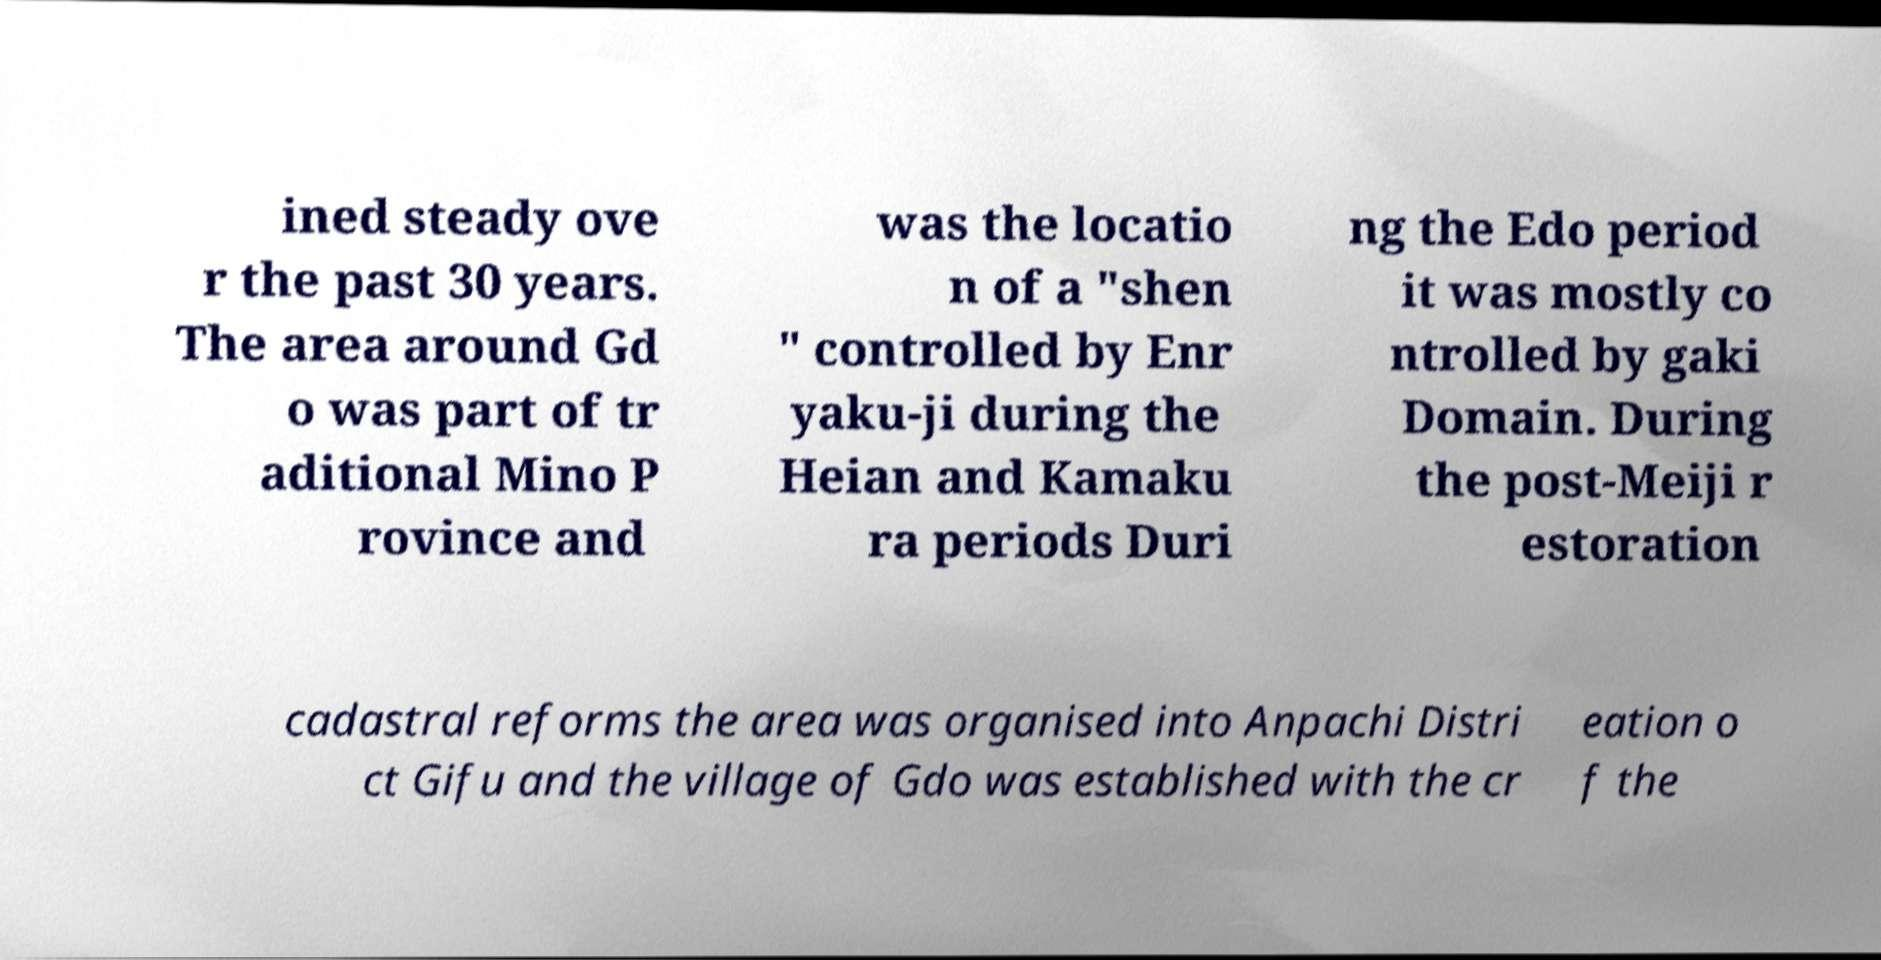Could you assist in decoding the text presented in this image and type it out clearly? ined steady ove r the past 30 years. The area around Gd o was part of tr aditional Mino P rovince and was the locatio n of a "shen " controlled by Enr yaku-ji during the Heian and Kamaku ra periods Duri ng the Edo period it was mostly co ntrolled by gaki Domain. During the post-Meiji r estoration cadastral reforms the area was organised into Anpachi Distri ct Gifu and the village of Gdo was established with the cr eation o f the 